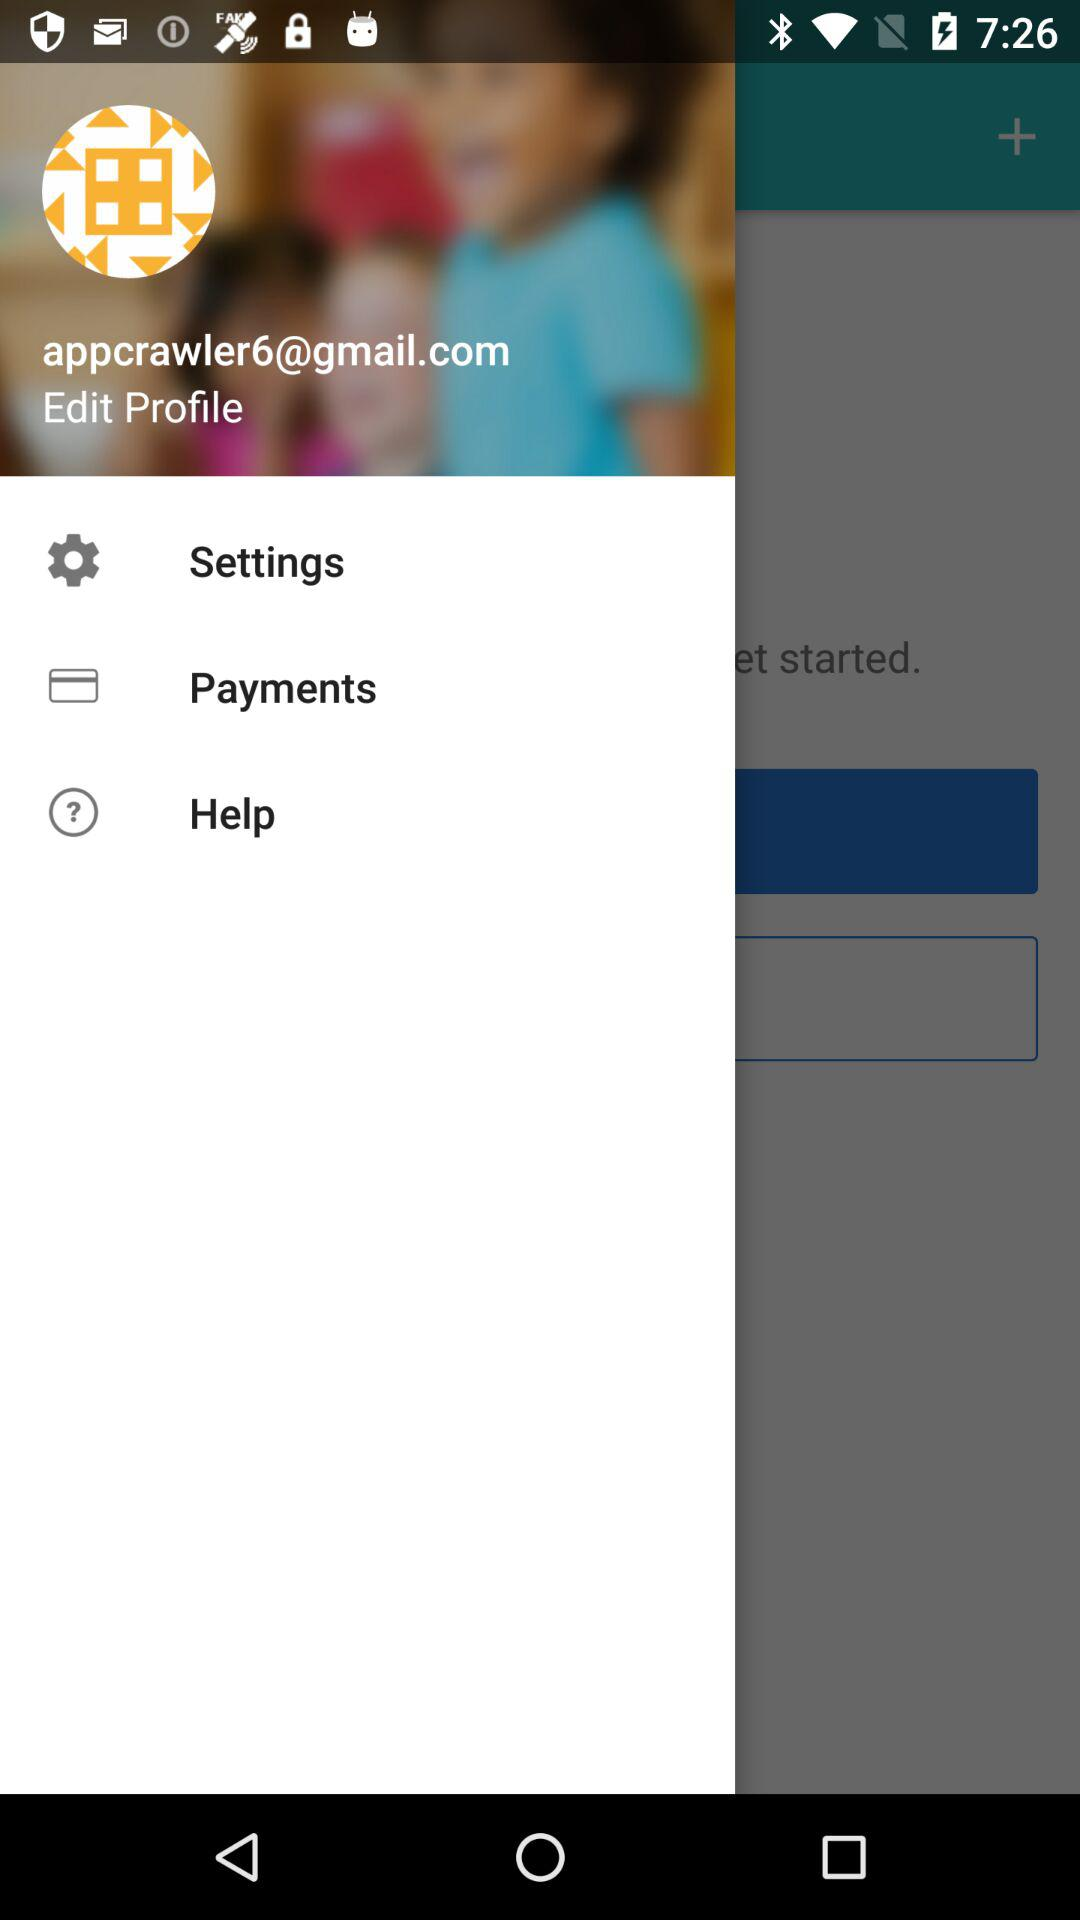What is the email address? The email address is appcrawler6@gmail.com. 